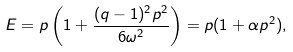<formula> <loc_0><loc_0><loc_500><loc_500>E = p \left ( 1 + \frac { ( q - 1 ) ^ { 2 } p ^ { 2 } } { 6 { \omega } ^ { 2 } } \right ) = p ( 1 + \alpha p ^ { 2 } ) ,</formula> 